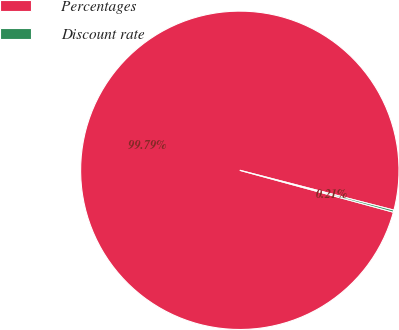<chart> <loc_0><loc_0><loc_500><loc_500><pie_chart><fcel>Percentages<fcel>Discount rate<nl><fcel>99.79%<fcel>0.21%<nl></chart> 